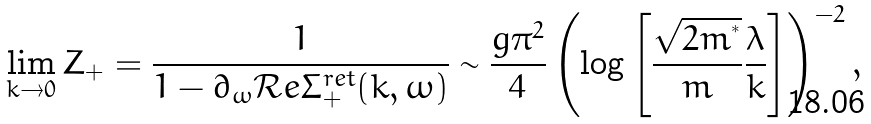Convert formula to latex. <formula><loc_0><loc_0><loc_500><loc_500>\lim _ { k \to 0 } Z _ { + } = \frac { 1 } { 1 - \partial _ { \omega } \mathcal { R } e \Sigma _ { + } ^ { r e t } ( k , \omega ) } \sim \frac { g \pi ^ { 2 } } { 4 } \left ( \log \left [ \frac { \sqrt { 2 m ^ { ^ { * } } } } { m } \frac { \lambda } { k } \right ] \right ) ^ { - 2 } ,</formula> 